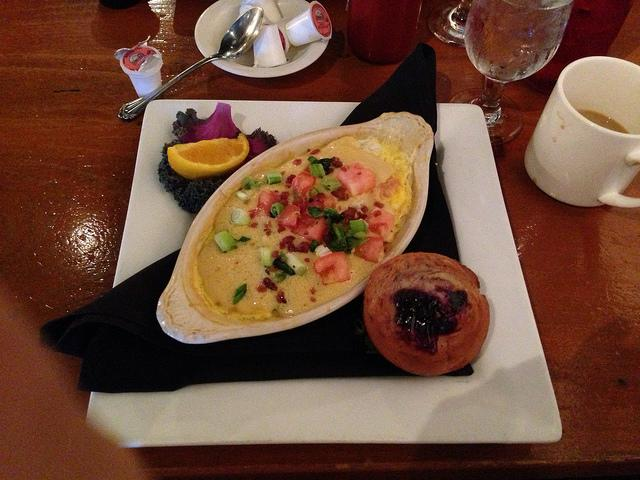What is in the little white plastic containers?

Choices:
A) coffee creamer
B) ketchup
C) jelly
D) butter coffee creamer 